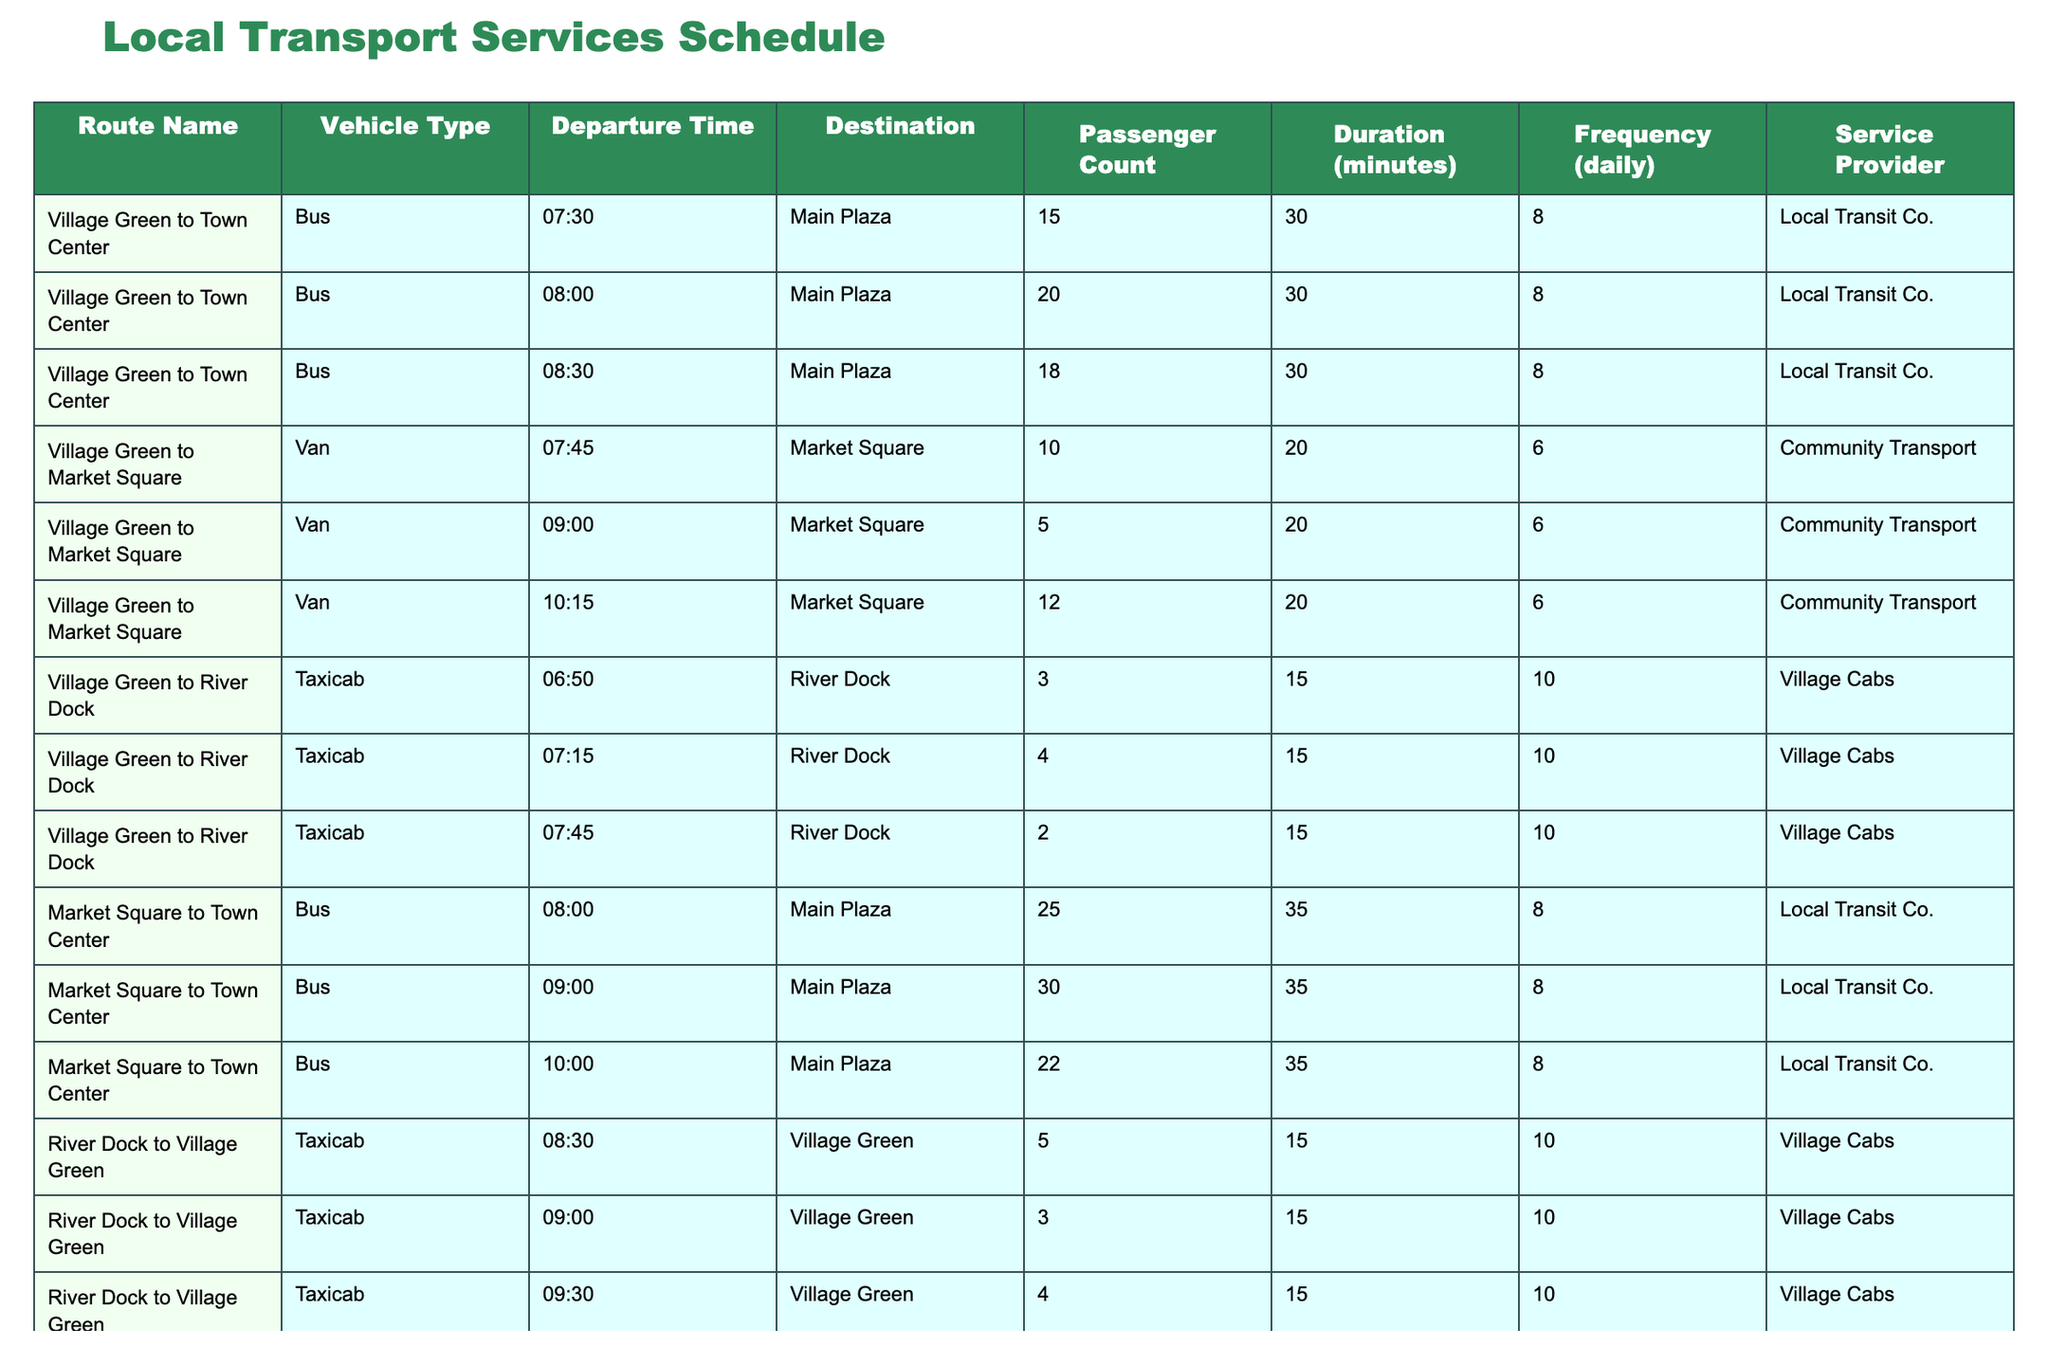What is the maximum passenger count for the route from Village Green to Town Center? By looking at the passenger counts in the table for the route from Village Green to Town Center, we see 15, 20, and 18. The highest of these numbers is 20.
Answer: 20 How many different vehicle types serve the Village Green to Market Square route? The table shows that the route from Village Green to Market Square is serviced by a van. There are no other types listed for this route, so there is only one type.
Answer: 1 What is the average duration of travel for the routes served by taxicabs? The travel durations for the taxicab routes (from Village Green to River Dock and back) are 15 minutes for each trip. Since there are three trips listed, the average is simply 15, as all durations are the same.
Answer: 15 Did any of the routes have more than 30 passengers? Checking the passenger counts for each route, the route Market Square to Town Center had 30 passengers at 09:00, and another route also reached 30 passengers, showing that more than 30 is not applicable.
Answer: No What is the total passenger count for all trips from Market Square to Town Center? The passenger counts for that route are 25, 30, and 22. Adding these numbers together, we have 25 + 30 + 22 = 77.
Answer: 77 Which route has the highest frequency of service? The service frequency is specified in the table, and the village route from Village Green to Town Center has a frequency of 8, which is higher than any other route listed.
Answer: Village Green to Town Center How does the passenger count for the 08:00 trip from Market Square to Town Center compare to trips at other times? Looking at the counts in the table, the 08:00 trip has 25 passengers, while the 09:00 trip has 30, and the 10:00 trip has 22. The 09:00 trip had more, while the others measured lower.
Answer: 25 What is the total duration for all trips from the Village Green to the River Dock? The duration for all taxicab trips listed to the River Dock is consistently 15 minutes each, with three trips. Thus, the total is calculated as 15 x 3 = 45 minutes in total.
Answer: 45 For which destination is the earliest bus from Village Green scheduled? The earliest scheduled bus from Village Green is at 07:30, traveling to the Town Center. So the earliest destination listed is Main Plaza.
Answer: Main Plaza What is the difference in passenger count between the highest and lowest counts for the Village Green to Market Square route? For that route, the counts are 10, 5, and 12. The highest count is 12 and the lowest is 5, so the difference is 12 - 5 = 7.
Answer: 7 Are there any shuttle services serving the route from Town Center to Market Square? Yes, the table lists shuttle services that provide transportation from Town Center to Market Square.
Answer: Yes 